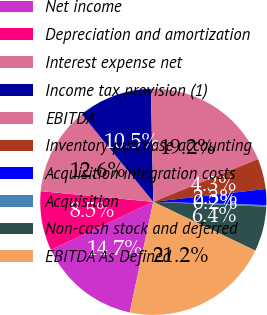Convert chart. <chart><loc_0><loc_0><loc_500><loc_500><pie_chart><fcel>Net income<fcel>Depreciation and amortization<fcel>Interest expense net<fcel>Income tax provision (1)<fcel>EBITDA<fcel>Inventory purchase accounting<fcel>Acquisition integration costs<fcel>Acquisition<fcel>Non-cash stock and deferred<fcel>EBITDA As Defined<nl><fcel>14.68%<fcel>8.48%<fcel>12.61%<fcel>10.55%<fcel>19.18%<fcel>4.35%<fcel>2.28%<fcel>0.22%<fcel>6.42%<fcel>21.24%<nl></chart> 